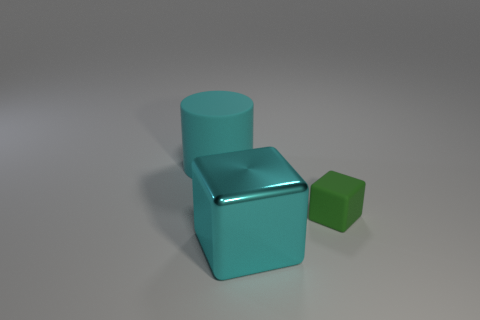Are there any other things that are the same size as the green block?
Offer a terse response. No. The rubber object that is on the right side of the cyan thing that is behind the large cyan thing in front of the green rubber cube is what color?
Offer a very short reply. Green. What number of other objects are the same shape as the small rubber object?
Your answer should be compact. 1. What shape is the big cyan thing behind the small green thing?
Offer a very short reply. Cylinder. Is there a big object that is in front of the large cyan object on the right side of the large cyan rubber cylinder?
Your response must be concise. No. What color is the thing that is behind the large cyan shiny thing and right of the large rubber object?
Provide a short and direct response. Green. Is there a thing to the left of the large cyan thing to the left of the block that is in front of the small object?
Your response must be concise. No. The cyan metallic thing that is the same shape as the tiny rubber thing is what size?
Provide a succinct answer. Large. Is there anything else that is made of the same material as the cyan cube?
Keep it short and to the point. No. Are any large cyan cubes visible?
Your response must be concise. Yes. 